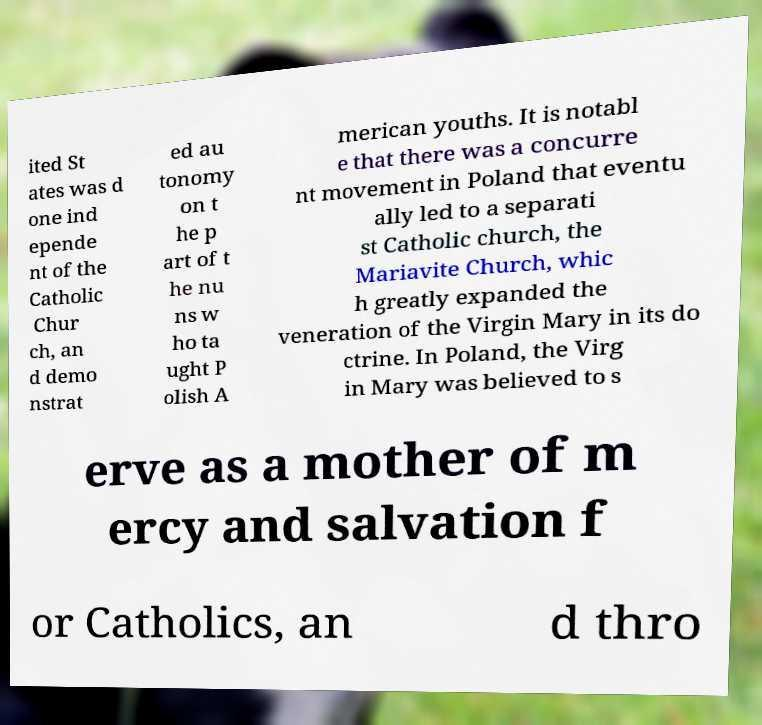Can you accurately transcribe the text from the provided image for me? ited St ates was d one ind epende nt of the Catholic Chur ch, an d demo nstrat ed au tonomy on t he p art of t he nu ns w ho ta ught P olish A merican youths. It is notabl e that there was a concurre nt movement in Poland that eventu ally led to a separati st Catholic church, the Mariavite Church, whic h greatly expanded the veneration of the Virgin Mary in its do ctrine. In Poland, the Virg in Mary was believed to s erve as a mother of m ercy and salvation f or Catholics, an d thro 